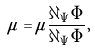<formula> <loc_0><loc_0><loc_500><loc_500>\tilde { \mu } = \mu \frac { \partial _ { \tilde { \Psi } } \Phi } { \partial _ { \Psi } \Phi } ,</formula> 